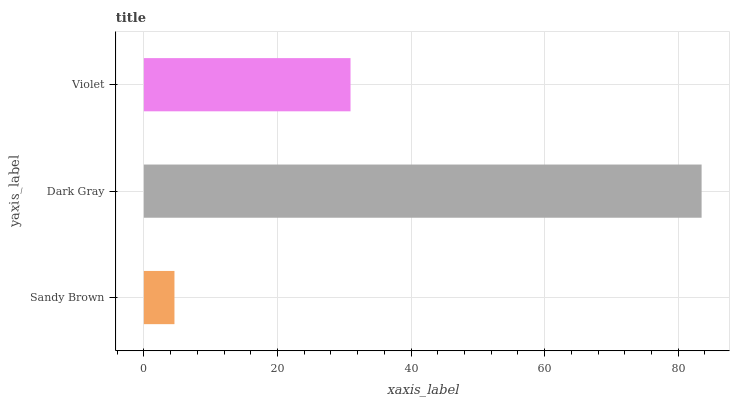Is Sandy Brown the minimum?
Answer yes or no. Yes. Is Dark Gray the maximum?
Answer yes or no. Yes. Is Violet the minimum?
Answer yes or no. No. Is Violet the maximum?
Answer yes or no. No. Is Dark Gray greater than Violet?
Answer yes or no. Yes. Is Violet less than Dark Gray?
Answer yes or no. Yes. Is Violet greater than Dark Gray?
Answer yes or no. No. Is Dark Gray less than Violet?
Answer yes or no. No. Is Violet the high median?
Answer yes or no. Yes. Is Violet the low median?
Answer yes or no. Yes. Is Dark Gray the high median?
Answer yes or no. No. Is Sandy Brown the low median?
Answer yes or no. No. 